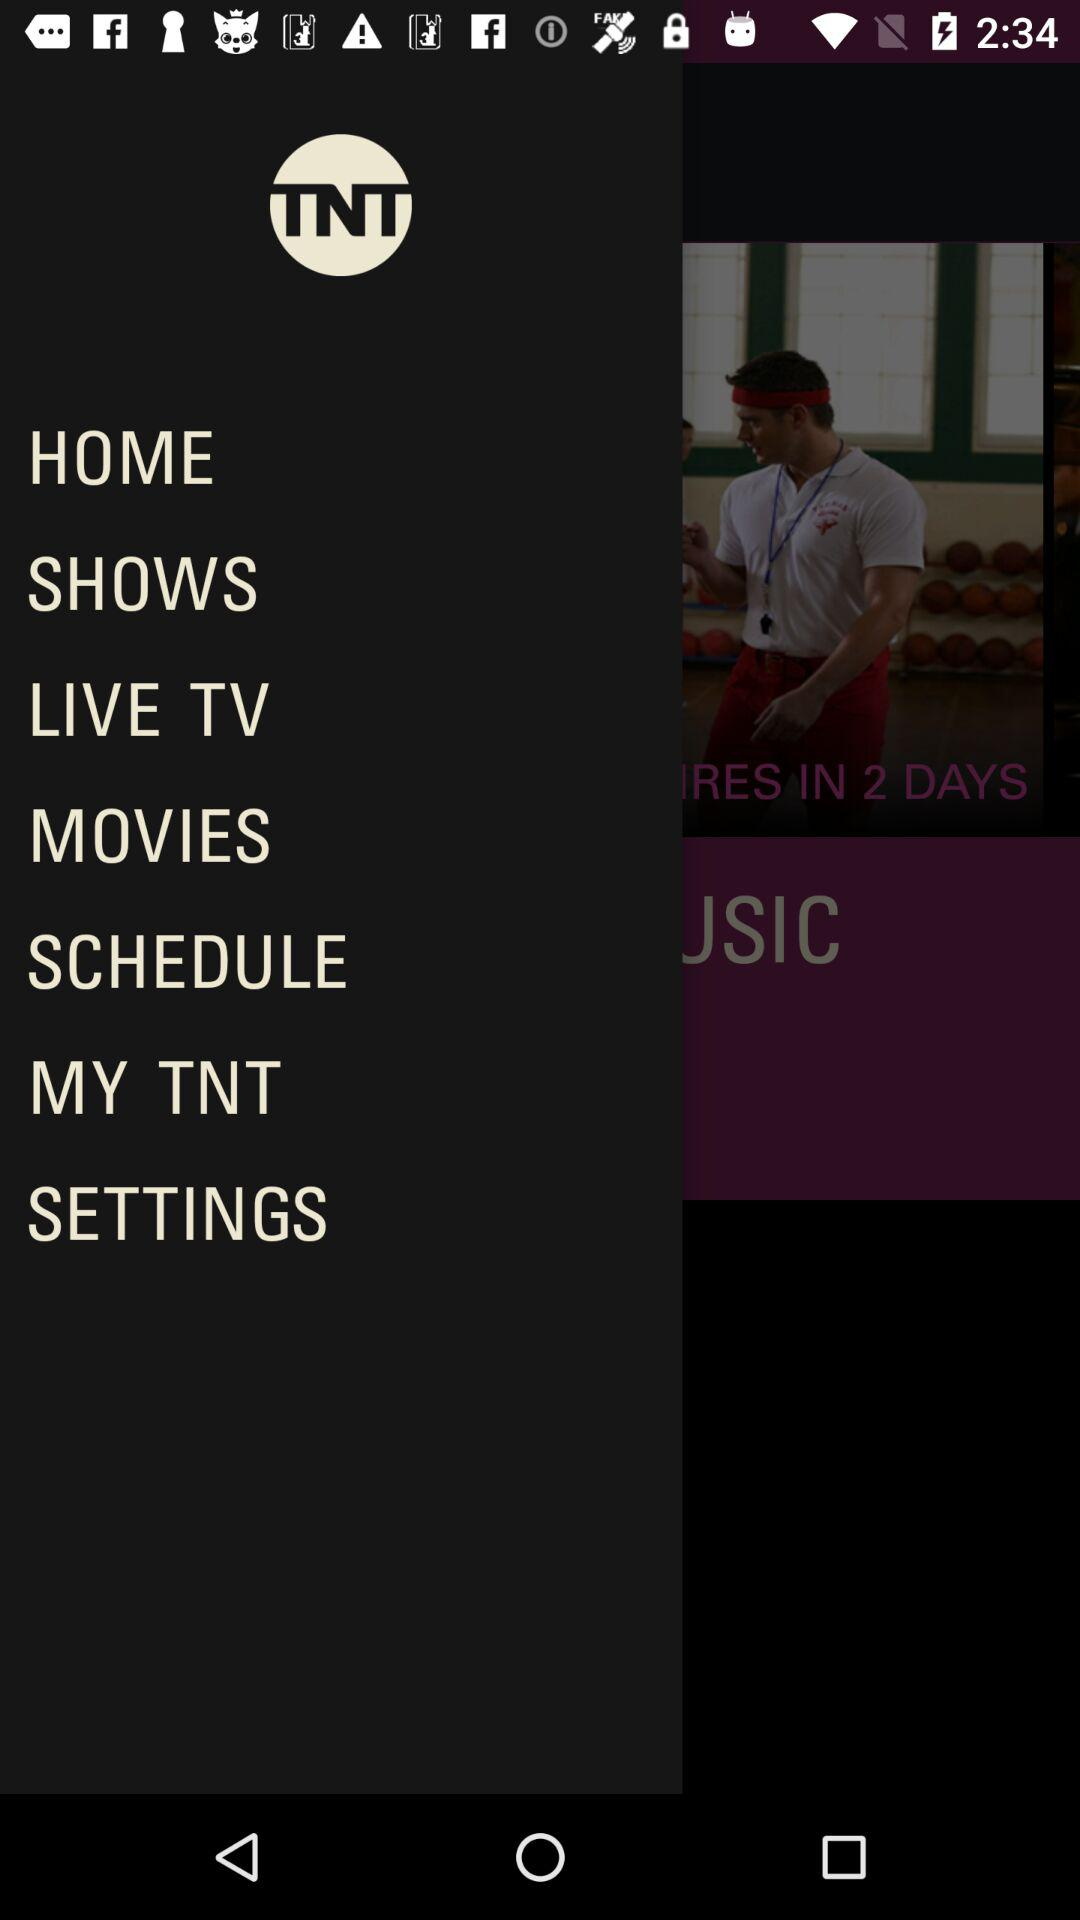What is the application name? The application name is "TNT". 